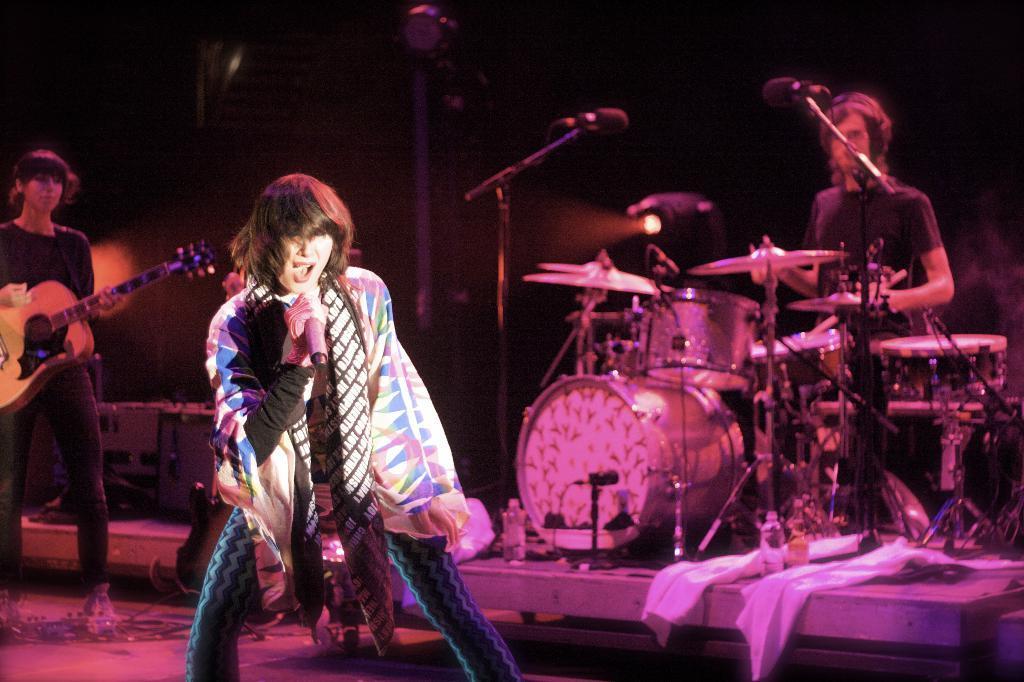Could you give a brief overview of what you see in this image? In this picture we can see a woman who is singing on the mike. On the left side of the picture we can see a person who is playing a guitar. And here we can see a person who is playing some musical instruments. And this is the mike. 